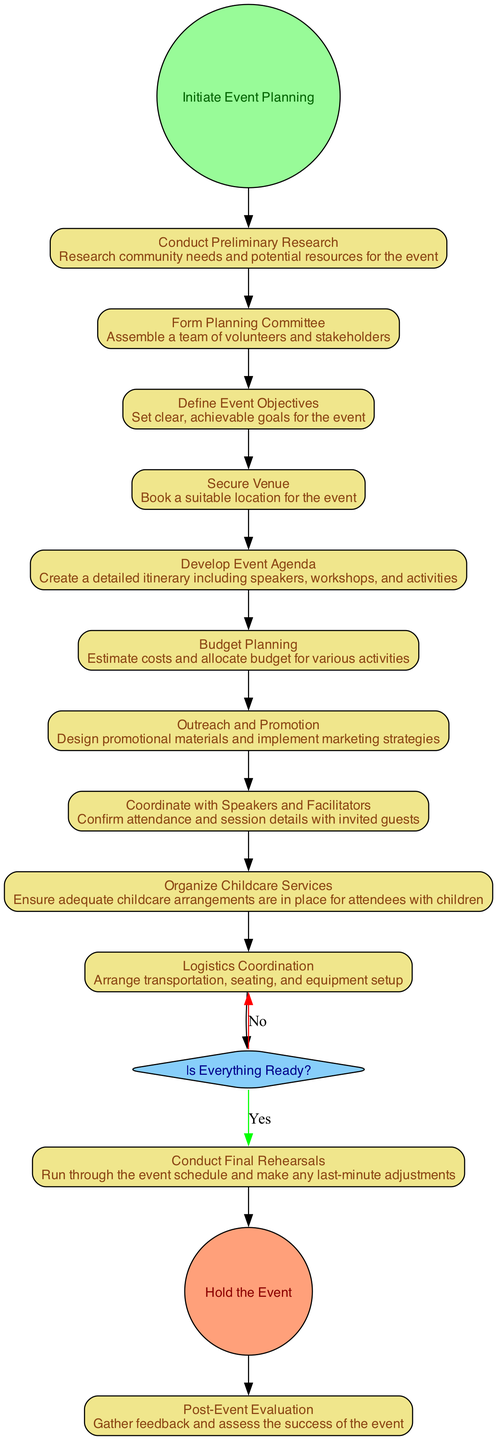What is the first activity in the diagram? The first activity starts after the initiation of event planning, which proceeds to "Conduct Preliminary Research". The diagram flow starts from the Start Event, leading directly to this activity.
Answer: Conduct Preliminary Research How many activities are there in total? Counting all activities shown in the diagram, including the ones from preliminary research to the final evaluation, there are ten activities delineated in the flow.
Answer: Ten What is the decision point in the diagram? The decision point is labeled "Is Everything Ready?". At this stage, a check is made on whether all preparations are completed before proceeding with the final rehearsals or returning to previous activities.
Answer: Is Everything Ready? Which activity focuses on arranging childcare? The activity specifically designated to ensure adequate childcare services for attendees with children is "Organize Childcare Services". This is part of managing logistics for the event.
Answer: Organize Childcare Services What activity directly follows the decision point if everything is ready? If everything is ready, the activity that follows the decision point "Is Everything Ready?" is "Conduct Final Rehearsals". This indicates preparations are confirmed before the event takes place.
Answer: Conduct Final Rehearsals What is the last activity depicted in the diagram? The last activity in the event organization process, as shown in the diagram, is "Post-Event Evaluation". This reflects the importance of assessing the success of the event after it has taken place.
Answer: Post-Event Evaluation Which activity involves confirming session details with speakers? The activity focused on confirming attendance and details with invited speakers is "Coordinate with Speakers and Facilitators". This activity ensures all session logistics are finalized.
Answer: Coordinate with Speakers and Facilitators What is the purpose of "Budget Planning"? The purpose of "Budget Planning" is to estimate costs and allocate budget for various activities. It plays a critical role in ensuring financial resources are appropriately managed for the event.
Answer: Estimate costs and allocate budget 